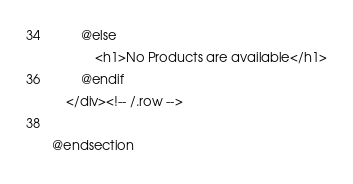Convert code to text. <code><loc_0><loc_0><loc_500><loc_500><_PHP_>        @else
            <h1>No Products are available</h1>
        @endif
    </div><!-- /.row -->

@endsection</code> 